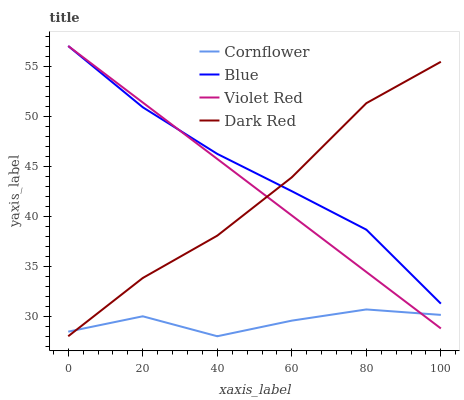Does Cornflower have the minimum area under the curve?
Answer yes or no. Yes. Does Blue have the maximum area under the curve?
Answer yes or no. Yes. Does Violet Red have the minimum area under the curve?
Answer yes or no. No. Does Violet Red have the maximum area under the curve?
Answer yes or no. No. Is Violet Red the smoothest?
Answer yes or no. Yes. Is Cornflower the roughest?
Answer yes or no. Yes. Is Cornflower the smoothest?
Answer yes or no. No. Is Violet Red the roughest?
Answer yes or no. No. Does Cornflower have the lowest value?
Answer yes or no. Yes. Does Violet Red have the lowest value?
Answer yes or no. No. Does Violet Red have the highest value?
Answer yes or no. Yes. Does Cornflower have the highest value?
Answer yes or no. No. Is Cornflower less than Blue?
Answer yes or no. Yes. Is Blue greater than Cornflower?
Answer yes or no. Yes. Does Dark Red intersect Violet Red?
Answer yes or no. Yes. Is Dark Red less than Violet Red?
Answer yes or no. No. Is Dark Red greater than Violet Red?
Answer yes or no. No. Does Cornflower intersect Blue?
Answer yes or no. No. 